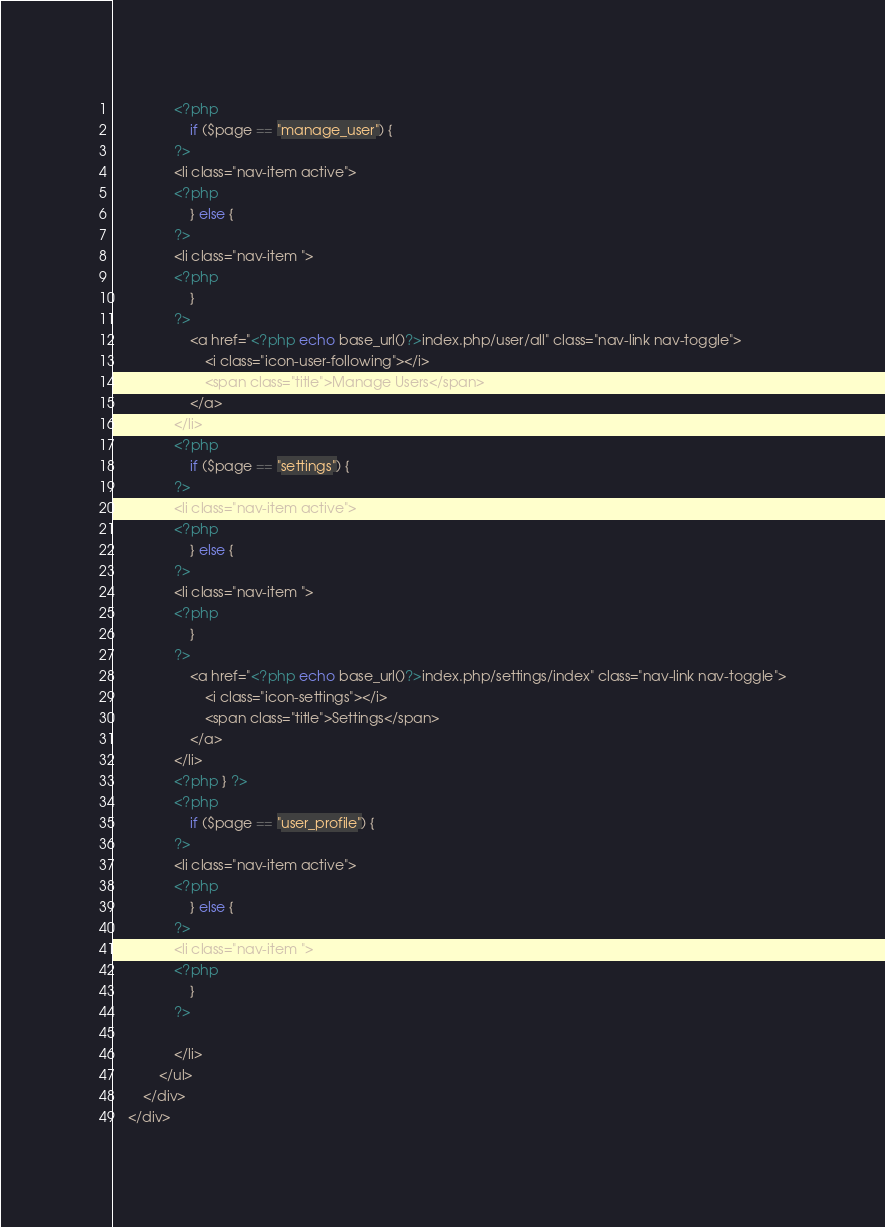<code> <loc_0><loc_0><loc_500><loc_500><_PHP_>                <?php 
                    if ($page == "manage_user") {
                ?>
                <li class="nav-item active">
                <?php
                    } else {
                ?>
                <li class="nav-item ">
                <?php
                    }
                ?>  
                    <a href="<?php echo base_url()?>index.php/user/all" class="nav-link nav-toggle">
                        <i class="icon-user-following"></i>
                        <span class="title">Manage Users</span>
                    </a>
                </li>
                <?php 
                    if ($page == "settings") {
                ?>
                <li class="nav-item active">
                <?php
                    } else {
                ?>
                <li class="nav-item ">
                <?php
                    }
                ?>  
                    <a href="<?php echo base_url()?>index.php/settings/index" class="nav-link nav-toggle">
                        <i class="icon-settings"></i>
                        <span class="title">Settings</span>
                    </a>
                </li>
                <?php } ?>
                <?php 
                    if ($page == "user_profile") {
                ?>
                <li class="nav-item active">
                <?php
                    } else {
                ?>
                <li class="nav-item ">
                <?php
                    }
                ?>  
                    
                </li>
            </ul>
        </div>
    </div></code> 